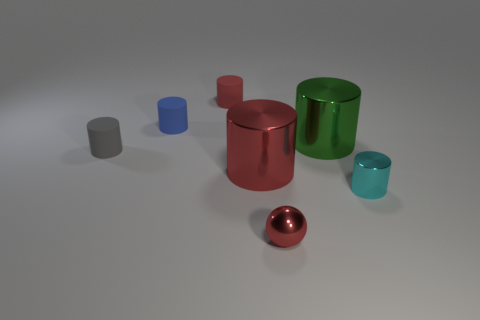Subtract all cyan cylinders. How many cylinders are left? 5 Subtract all gray cylinders. How many cylinders are left? 5 Subtract all blue cylinders. Subtract all purple spheres. How many cylinders are left? 5 Add 1 tiny gray cylinders. How many objects exist? 8 Subtract all cylinders. How many objects are left? 1 Subtract 0 purple cylinders. How many objects are left? 7 Subtract all big gray spheres. Subtract all tiny rubber objects. How many objects are left? 4 Add 4 red spheres. How many red spheres are left? 5 Add 1 big cylinders. How many big cylinders exist? 3 